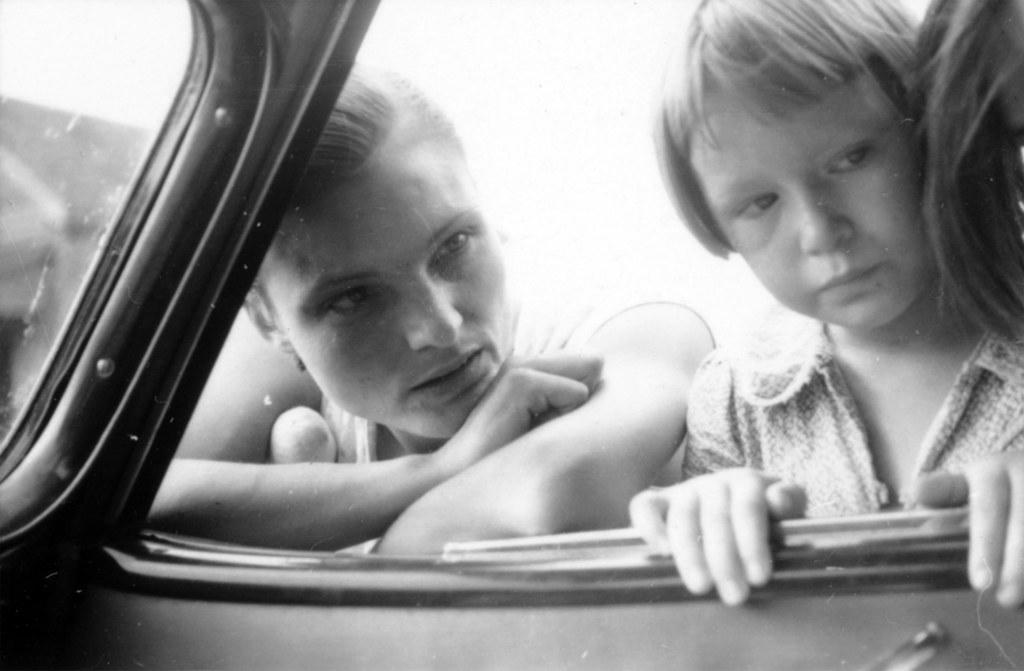What is the color scheme of the image? The image is black and white. How many people are in the image? There are two persons in the image. What are the two persons doing in the image? The two persons are standing and staring. What type of carriage can be seen in the image? There is no carriage present in the image; it is a black and white image of two persons standing and staring. 